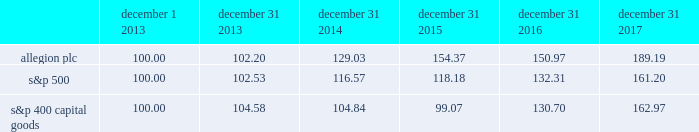Performance graph the annual changes for the period shown december 1 , 2013 ( when our ordinary shares began trading ) to december 31 , 2017 in the graph on this page are based on the assumption that $ 100 had been invested in allegion plc ordinary shares , the standard & poor 2019s 500 stock index ( "s&p 500" ) and the standard & poor's 400 capital goods index ( "s&p 400 capital goods" ) on december 1 , 2013 , and that all quarterly dividends were reinvested .
The total cumulative dollar returns shown on the graph represent the value that such investments would have had on december 31 , 2017 .
December 1 , december 31 , december 31 , december 31 , december 31 , december 31 .

What is the annualized return for the investment in the allegion plc during 2013-2017? 
Rationale: it is the compound interest formula , in which the period is 4 years to transform the accumulated interest into an annual return.\\n
Computations: (((189.19 - 100) ** ((1 / 4) - 1)) - 1)
Answer: -0.96554. 